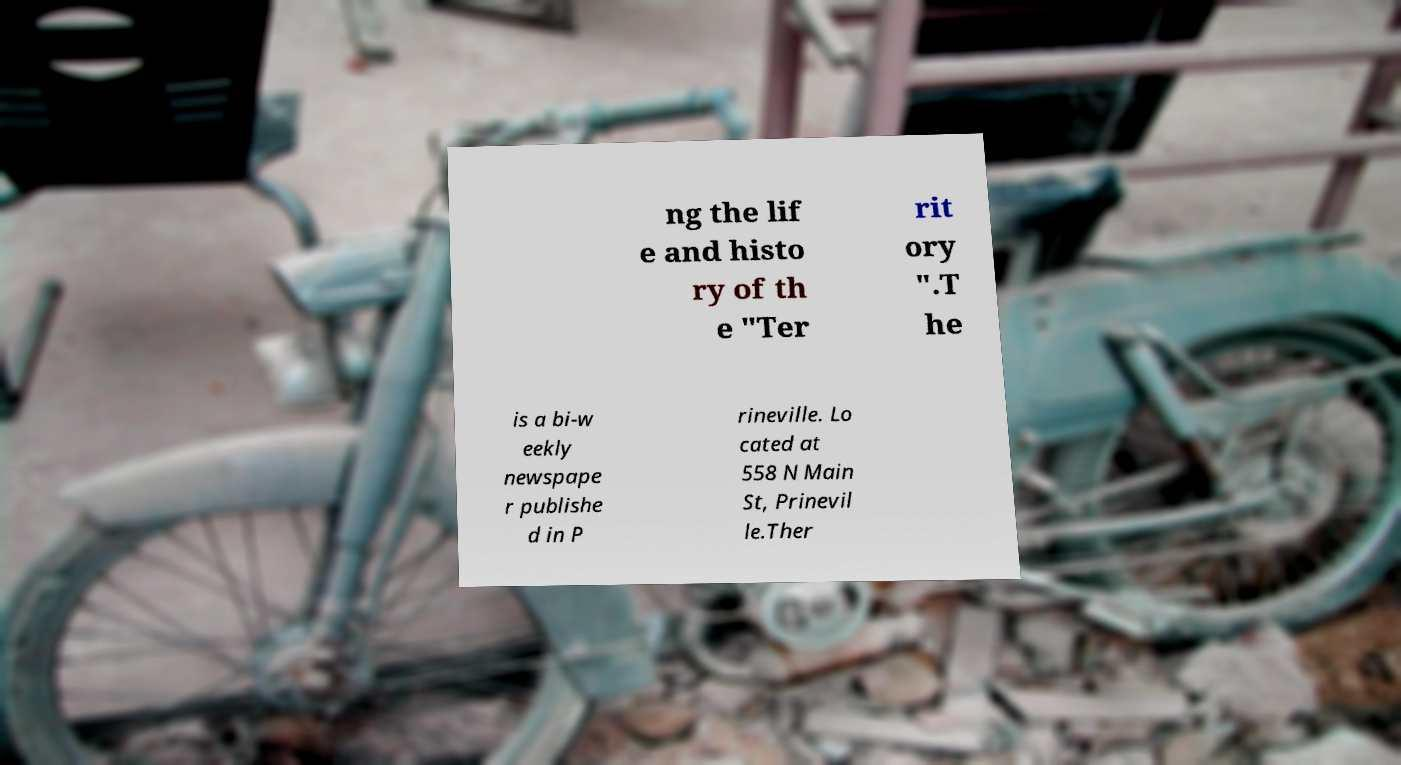Could you assist in decoding the text presented in this image and type it out clearly? ng the lif e and histo ry of th e "Ter rit ory ".T he is a bi-w eekly newspape r publishe d in P rineville. Lo cated at 558 N Main St, Prinevil le.Ther 